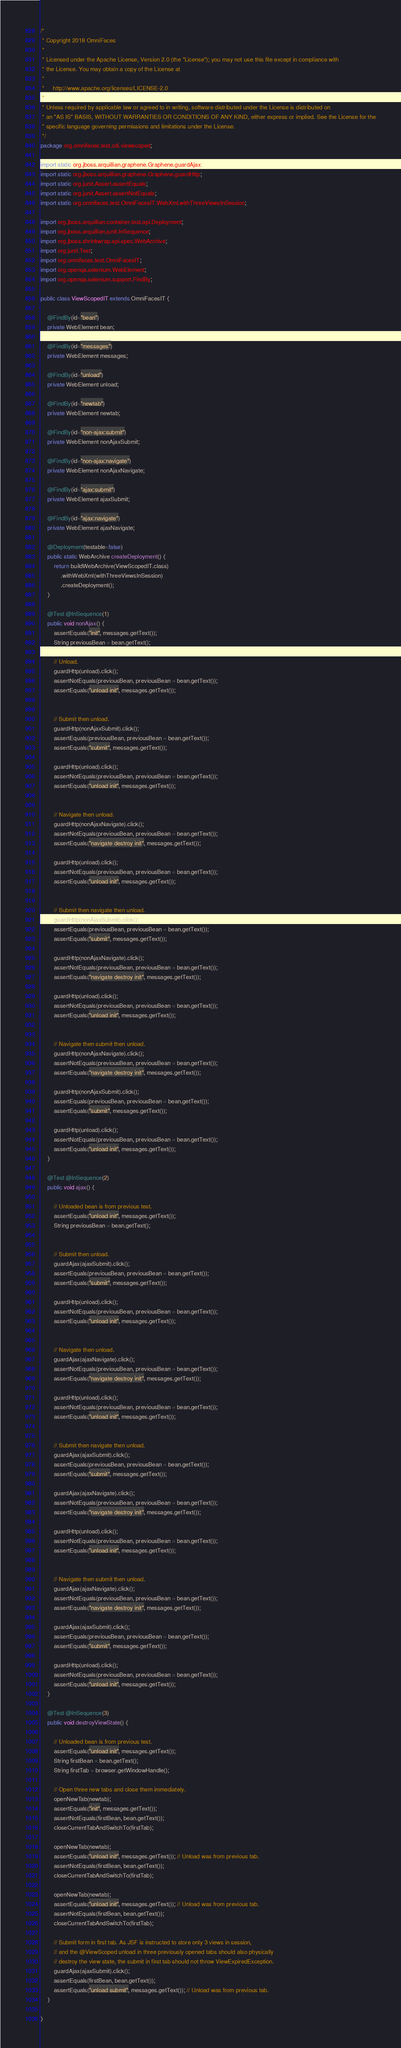<code> <loc_0><loc_0><loc_500><loc_500><_Java_>/*
 * Copyright 2018 OmniFaces
 *
 * Licensed under the Apache License, Version 2.0 (the "License"); you may not use this file except in compliance with
 * the License. You may obtain a copy of the License at
 *
 *     http://www.apache.org/licenses/LICENSE-2.0
 *
 * Unless required by applicable law or agreed to in writing, software distributed under the License is distributed on
 * an "AS IS" BASIS, WITHOUT WARRANTIES OR CONDITIONS OF ANY KIND, either express or implied. See the License for the
 * specific language governing permissions and limitations under the License.
 */
package org.omnifaces.test.cdi.viewscoped;

import static org.jboss.arquillian.graphene.Graphene.guardAjax;
import static org.jboss.arquillian.graphene.Graphene.guardHttp;
import static org.junit.Assert.assertEquals;
import static org.junit.Assert.assertNotEquals;
import static org.omnifaces.test.OmniFacesIT.WebXml.withThreeViewsInSession;

import org.jboss.arquillian.container.test.api.Deployment;
import org.jboss.arquillian.junit.InSequence;
import org.jboss.shrinkwrap.api.spec.WebArchive;
import org.junit.Test;
import org.omnifaces.test.OmniFacesIT;
import org.openqa.selenium.WebElement;
import org.openqa.selenium.support.FindBy;

public class ViewScopedIT extends OmniFacesIT {

	@FindBy(id="bean")
	private WebElement bean;

	@FindBy(id="messages")
	private WebElement messages;

	@FindBy(id="unload")
	private WebElement unload;

	@FindBy(id="newtab")
	private WebElement newtab;

	@FindBy(id="non-ajax:submit")
	private WebElement nonAjaxSubmit;

	@FindBy(id="non-ajax:navigate")
	private WebElement nonAjaxNavigate;

	@FindBy(id="ajax:submit")
	private WebElement ajaxSubmit;

	@FindBy(id="ajax:navigate")
	private WebElement ajaxNavigate;

	@Deployment(testable=false)
	public static WebArchive createDeployment() {
		return buildWebArchive(ViewScopedIT.class)
			.withWebXml(withThreeViewsInSession)
			.createDeployment();
	}

	@Test @InSequence(1)
	public void nonAjax() {
		assertEquals("init", messages.getText());
		String previousBean = bean.getText();

		// Unload.
		guardHttp(unload).click();
		assertNotEquals(previousBean, previousBean = bean.getText());
		assertEquals("unload init", messages.getText());


		// Submit then unload.
		guardHttp(nonAjaxSubmit).click();
		assertEquals(previousBean, previousBean = bean.getText());
		assertEquals("submit", messages.getText());

		guardHttp(unload).click();
		assertNotEquals(previousBean, previousBean = bean.getText());
		assertEquals("unload init", messages.getText());


		// Navigate then unload.
		guardHttp(nonAjaxNavigate).click();
		assertNotEquals(previousBean, previousBean = bean.getText());
		assertEquals("navigate destroy init", messages.getText());

		guardHttp(unload).click();
		assertNotEquals(previousBean, previousBean = bean.getText());
		assertEquals("unload init", messages.getText());


		// Submit then navigate then unload.
		guardHttp(nonAjaxSubmit).click();
		assertEquals(previousBean, previousBean = bean.getText());
		assertEquals("submit", messages.getText());

		guardHttp(nonAjaxNavigate).click();
		assertNotEquals(previousBean, previousBean = bean.getText());
		assertEquals("navigate destroy init", messages.getText());

		guardHttp(unload).click();
		assertNotEquals(previousBean, previousBean = bean.getText());
		assertEquals("unload init", messages.getText());


		// Navigate then submit then unload.
		guardHttp(nonAjaxNavigate).click();
		assertNotEquals(previousBean, previousBean = bean.getText());
		assertEquals("navigate destroy init", messages.getText());

		guardHttp(nonAjaxSubmit).click();
		assertEquals(previousBean, previousBean = bean.getText());
		assertEquals("submit", messages.getText());

		guardHttp(unload).click();
		assertNotEquals(previousBean, previousBean = bean.getText());
		assertEquals("unload init", messages.getText());
	}

	@Test @InSequence(2)
	public void ajax() {

		// Unloaded bean is from previous test.
		assertEquals("unload init", messages.getText());
		String previousBean = bean.getText();


		// Submit then unload.
		guardAjax(ajaxSubmit).click();
		assertEquals(previousBean, previousBean = bean.getText());
		assertEquals("submit", messages.getText());

		guardHttp(unload).click();
		assertNotEquals(previousBean, previousBean = bean.getText());
		assertEquals("unload init", messages.getText());


		// Navigate then unload.
		guardAjax(ajaxNavigate).click();
		assertNotEquals(previousBean, previousBean = bean.getText());
		assertEquals("navigate destroy init", messages.getText());

		guardHttp(unload).click();
		assertNotEquals(previousBean, previousBean = bean.getText());
		assertEquals("unload init", messages.getText());


		// Submit then navigate then unload.
		guardAjax(ajaxSubmit).click();
		assertEquals(previousBean, previousBean = bean.getText());
		assertEquals("submit", messages.getText());

		guardAjax(ajaxNavigate).click();
		assertNotEquals(previousBean, previousBean = bean.getText());
		assertEquals("navigate destroy init", messages.getText());

		guardHttp(unload).click();
		assertNotEquals(previousBean, previousBean = bean.getText());
		assertEquals("unload init", messages.getText());


		// Navigate then submit then unload.
		guardAjax(ajaxNavigate).click();
		assertNotEquals(previousBean, previousBean = bean.getText());
		assertEquals("navigate destroy init", messages.getText());

		guardAjax(ajaxSubmit).click();
		assertEquals(previousBean, previousBean = bean.getText());
		assertEquals("submit", messages.getText());

		guardHttp(unload).click();
		assertNotEquals(previousBean, previousBean = bean.getText());
		assertEquals("unload init", messages.getText());
	}

	@Test @InSequence(3)
	public void destroyViewState() {

		// Unloaded bean is from previous test.
		assertEquals("unload init", messages.getText());
		String firstBean = bean.getText();
		String firstTab = browser.getWindowHandle();

		// Open three new tabs and close them immediately.
		openNewTab(newtab);
		assertEquals("init", messages.getText());
		assertNotEquals(firstBean, bean.getText());
		closeCurrentTabAndSwitchTo(firstTab);

		openNewTab(newtab);
		assertEquals("unload init", messages.getText()); // Unload was from previous tab.
		assertNotEquals(firstBean, bean.getText());
		closeCurrentTabAndSwitchTo(firstTab);

		openNewTab(newtab);
		assertEquals("unload init", messages.getText()); // Unload was from previous tab.
		assertNotEquals(firstBean, bean.getText());
		closeCurrentTabAndSwitchTo(firstTab);

		// Submit form in first tab. As JSF is instructed to store only 3 views in session,
		// and the @ViewScoped unload in three previously opened tabs should also physically
		// destroy the view state, the submit in first tab should not throw ViewExpiredException.
		guardAjax(ajaxSubmit).click();
		assertEquals(firstBean, bean.getText());
		assertEquals("unload submit", messages.getText()); // Unload was from previous tab.
	}

}</code> 